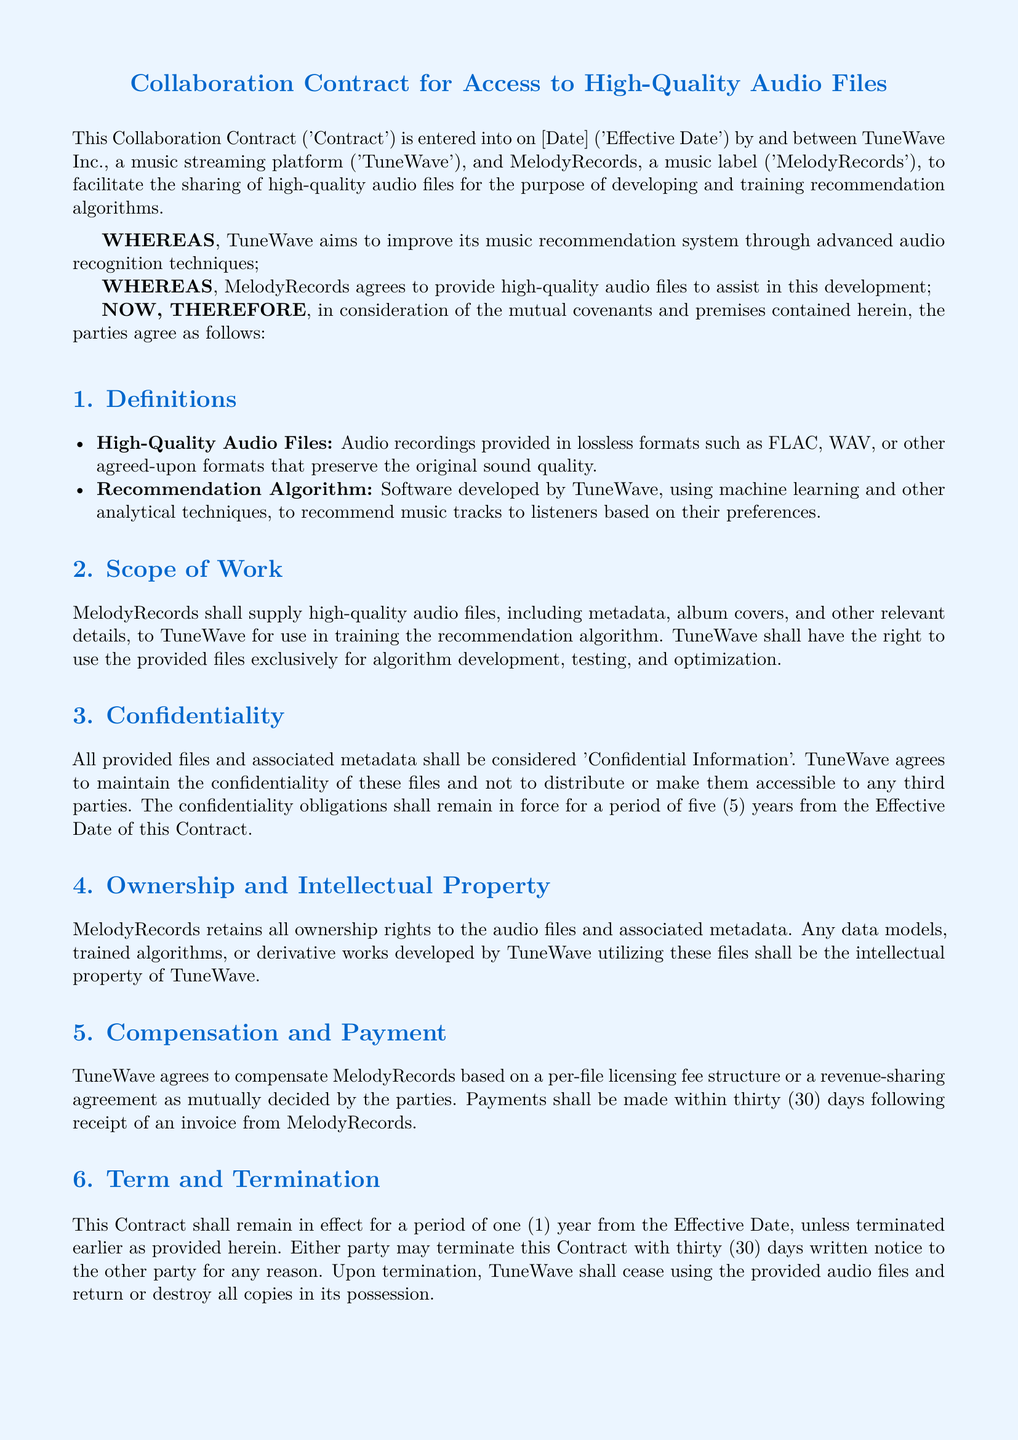What is the effective date? The effective date is specified as [Date] within the document.
Answer: [Date] Who is the agreement between? The agreement is made between TuneWave Inc. and MelodyRecords.
Answer: TuneWave Inc. and MelodyRecords What types of audio files are mentioned? The document specifies lossless formats such as FLAC and WAV as examples of high-quality audio files.
Answer: FLAC, WAV How long will the confidentiality obligations last? The confidentiality obligations are stated to remain in force for a period of five years from the effective date.
Answer: Five years What is the payment period after receiving an invoice? The document states that payments shall be made within thirty days following receipt of an invoice.
Answer: Thirty days Which state governs the contract? The governing law of the contract is mentioned as the State of California.
Answer: California What is the duration of the contract? The contract will remain effective for a period of one year from the effective date.
Answer: One year What action must TuneWave take upon termination of the contract? Upon termination, TuneWave is required to cease using the provided audio files and return or destroy all copies in its possession.
Answer: Cease using and return or destroy copies What type of arbitration is specified for dispute resolution? The disputes under the contract are to be resolved through binding arbitration according to the mentioned rules.
Answer: Binding arbitration 